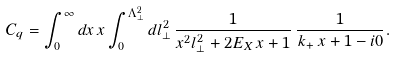Convert formula to latex. <formula><loc_0><loc_0><loc_500><loc_500>C _ { q } = \int _ { 0 } ^ { \infty } d x \, x \int _ { 0 } ^ { \Lambda _ { \perp } ^ { 2 } } d l _ { \perp } ^ { 2 } \, \frac { 1 } { x ^ { 2 } l _ { \perp } ^ { 2 } + 2 E _ { X } \, x + 1 } \, \frac { 1 } { k _ { + } \, x + 1 - i 0 } .</formula> 